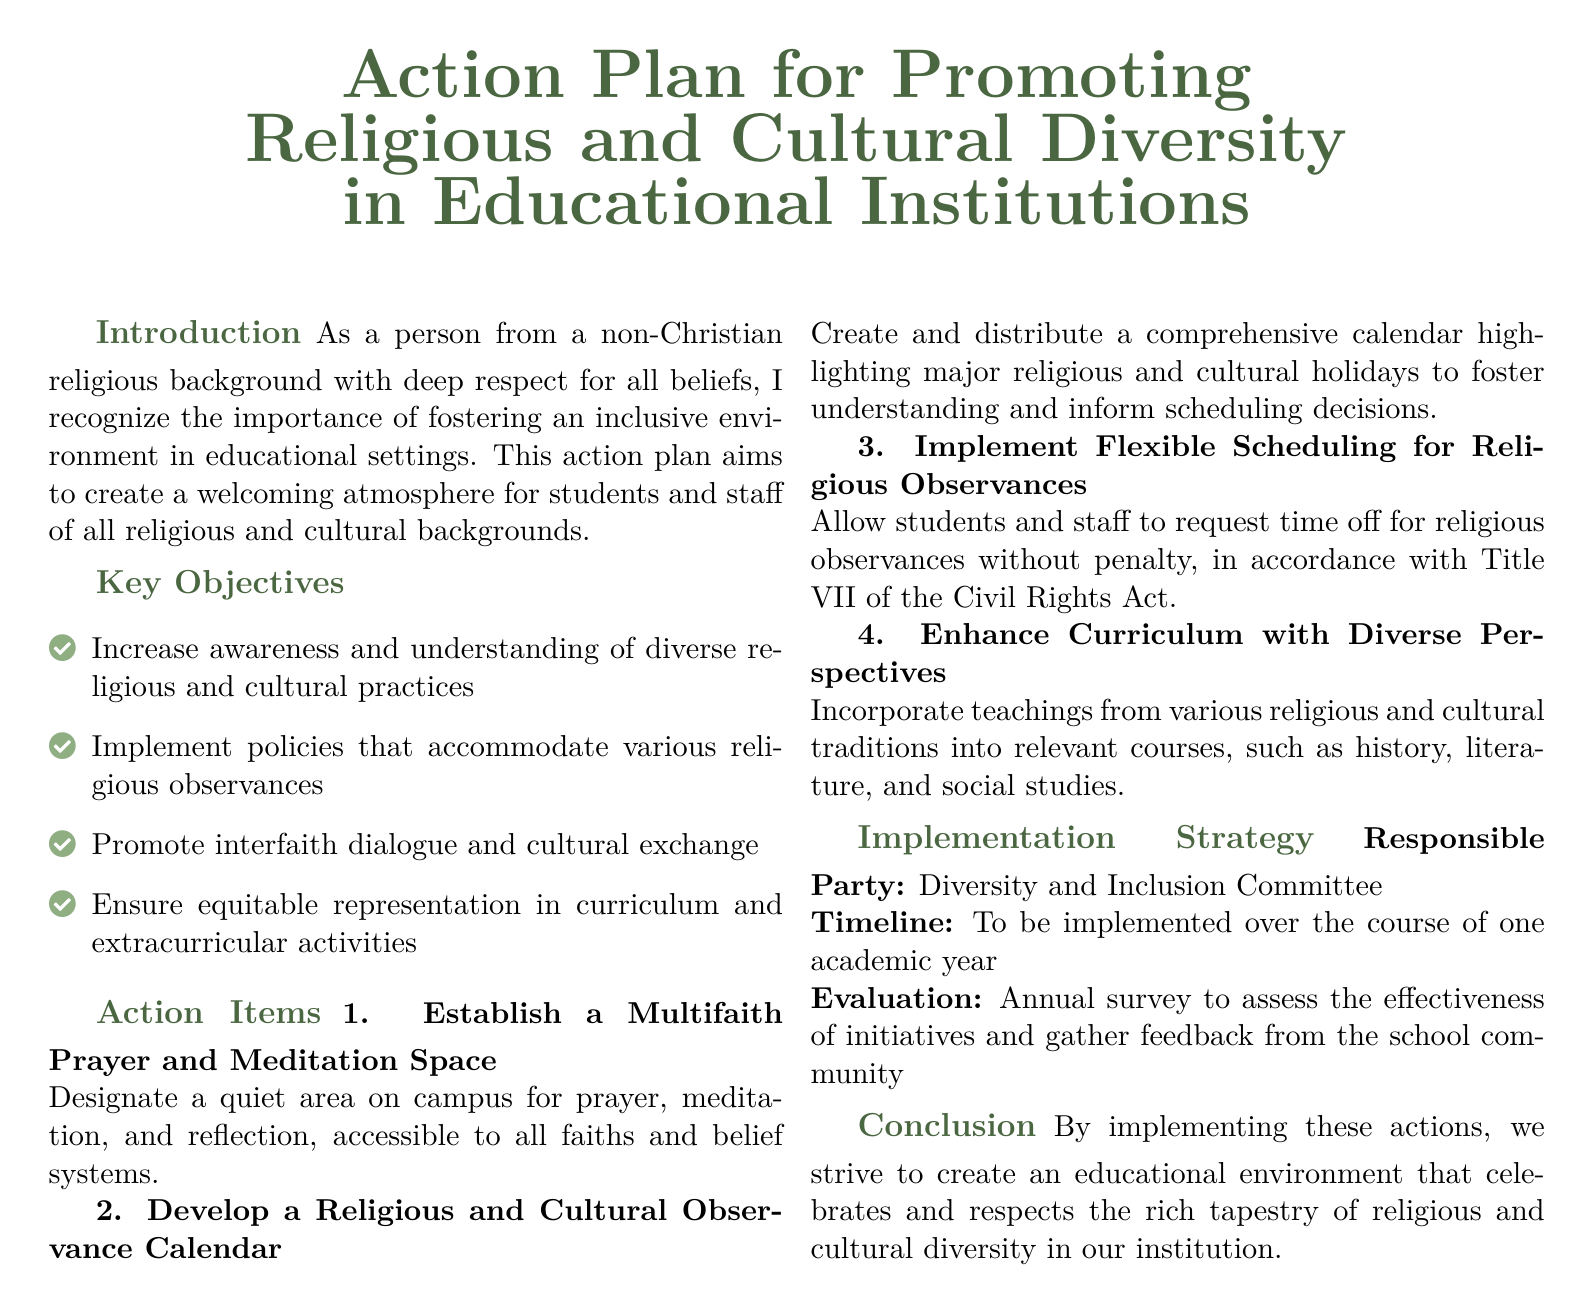What are the key objectives? The key objectives are listed in the document under "Key Objectives" section, which includes increasing awareness, implementing accommodating policies, promoting dialogue, and ensuring equitable representation.
Answer: Increase awareness and understanding of diverse religious and cultural practices; Implement policies that accommodate various religious observances; Promote interfaith dialogue and cultural exchange; Ensure equitable representation in curriculum and extracurricular activities Who is responsible for the implementation? The responsible party for implementation is mentioned in the "Implementation Strategy" section of the document.
Answer: Diversity and Inclusion Committee What is the timeline for implementation? The timeline for implementation is specified in the "Implementation Strategy" section, indicating when the actions are planned to take place.
Answer: One academic year What is one proposed action item? The document lists specific action items in the "Action Items" section, providing examples of initiatives to promote diversity.
Answer: Establish a Multifaith Prayer and Meditation Space What will be used to evaluate the initiatives? The evaluation method is described in the "Implementation Strategy" section, which outlines how feedback will be gathered.
Answer: Annual survey to assess the effectiveness of initiatives How many key objectives are listed? The total number of key objectives can be counted directly from the "Key Objectives" section of the document.
Answer: Four What is the purpose of the Religious and Cultural Observance Calendar? The purpose of the calendar is outlined under the relevant action item in the document, explaining its role in enhancing understanding.
Answer: To foster understanding and inform scheduling decisions What type of space will be established on campus? The type of space to be established is clearly defined in one of the proposed action items in the document.
Answer: Multifaith Prayer and Meditation Space What is the goal of the action plan? The overall goal of the action plan is stated in the "Conclusion" section, summarizing its intent and aspirations for the educational environment.
Answer: To create an educational environment that celebrates and respects the rich tapestry of religious and cultural diversity 